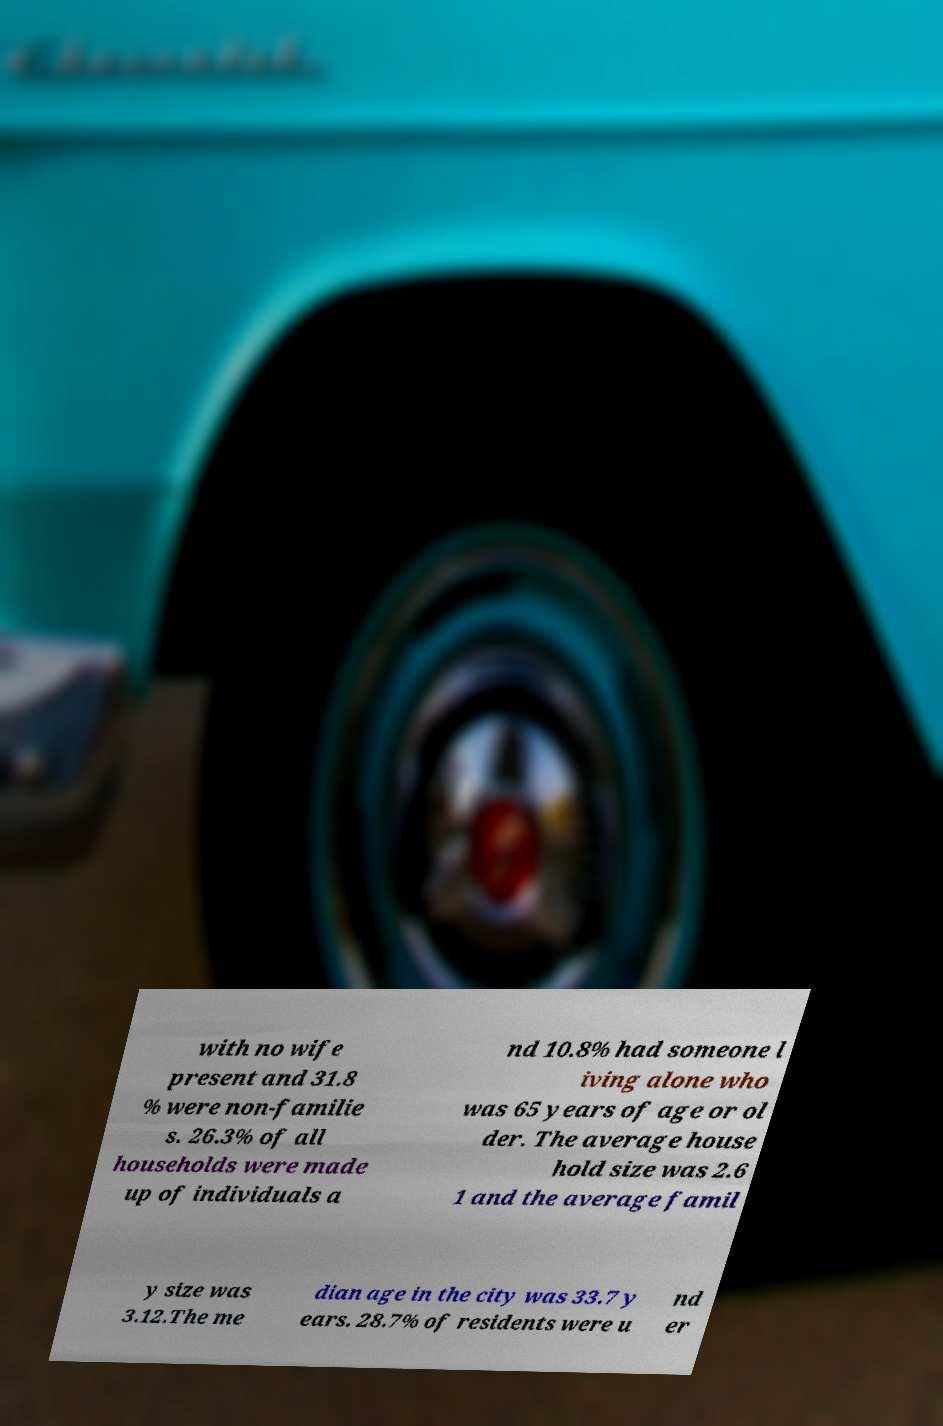Could you extract and type out the text from this image? with no wife present and 31.8 % were non-familie s. 26.3% of all households were made up of individuals a nd 10.8% had someone l iving alone who was 65 years of age or ol der. The average house hold size was 2.6 1 and the average famil y size was 3.12.The me dian age in the city was 33.7 y ears. 28.7% of residents were u nd er 